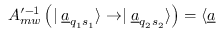<formula> <loc_0><loc_0><loc_500><loc_500>A _ { m w } ^ { \prime - 1 } \left ( | \underline { a } _ { q _ { 1 } s _ { 1 } } \rangle \rightarrow | \underline { a } _ { q _ { 2 } s _ { 2 } } \rangle \right ) = \langle \underline { a }</formula> 